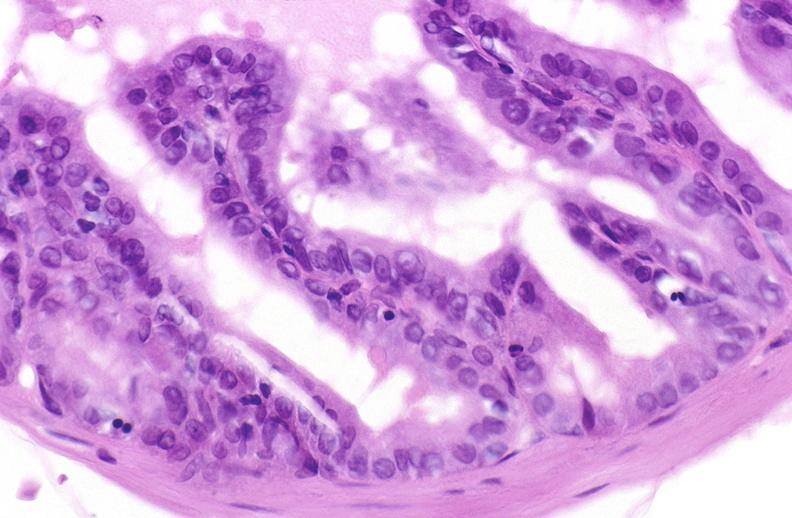what does this image show?
Answer the question using a single word or phrase. Apoptosis in prostate after orchiectomy 